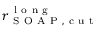Convert formula to latex. <formula><loc_0><loc_0><loc_500><loc_500>r _ { S O A P , c u t } ^ { l o n g }</formula> 